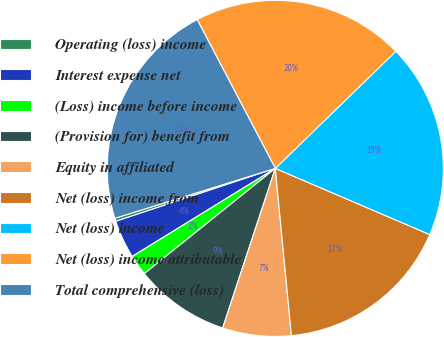Convert chart to OTSL. <chart><loc_0><loc_0><loc_500><loc_500><pie_chart><fcel>Operating (loss) income<fcel>Interest expense net<fcel>(Loss) income before income<fcel>(Provision for) benefit from<fcel>Equity in affiliated<fcel>Net (loss) income from<fcel>Net (loss) income<fcel>Net (loss) income attributable<fcel>Total comprehensive (loss)<nl><fcel>0.3%<fcel>3.68%<fcel>1.99%<fcel>9.16%<fcel>6.6%<fcel>17.03%<fcel>18.72%<fcel>20.42%<fcel>22.11%<nl></chart> 